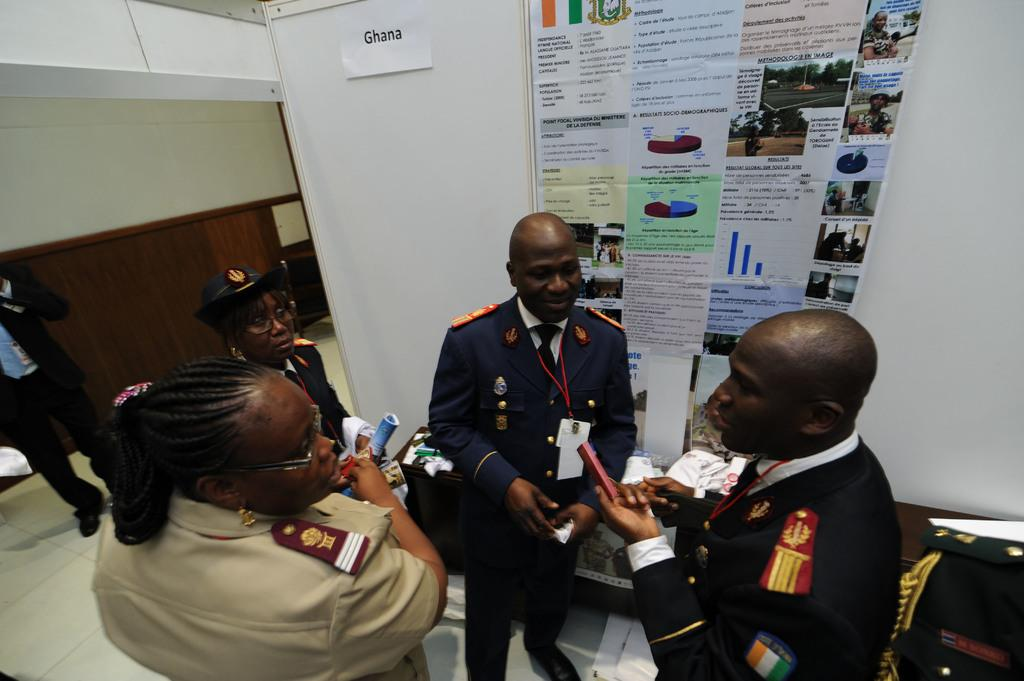What are the people in the image doing? The people in the image are on the floor. What can be seen in the background of the image? There is a wall, posters, and other objects visible in the background of the image. How does the paste help the bee in the image? There is no paste or bee present in the image. What type of work are the people doing in the image? The provided facts do not mention any specific work being done by the people in the image. 